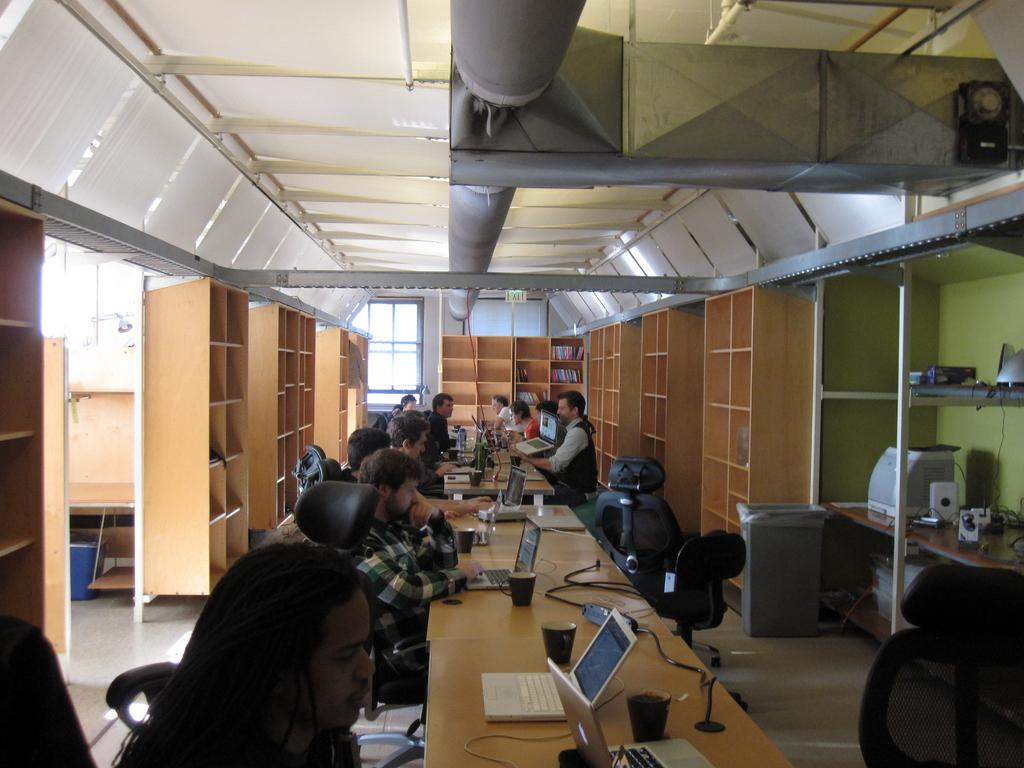What type of room is shown in the image? The image depicts an office room. What are the people in the room doing? The people are sitting on chairs and working on laptops. Are there any storage units in the room? Yes, there are shelves present in the room. How many toes can be seen on the people in the image? There is no way to determine the number of toes visible in the image, as the focus is on the people working on laptops and not their feet. 